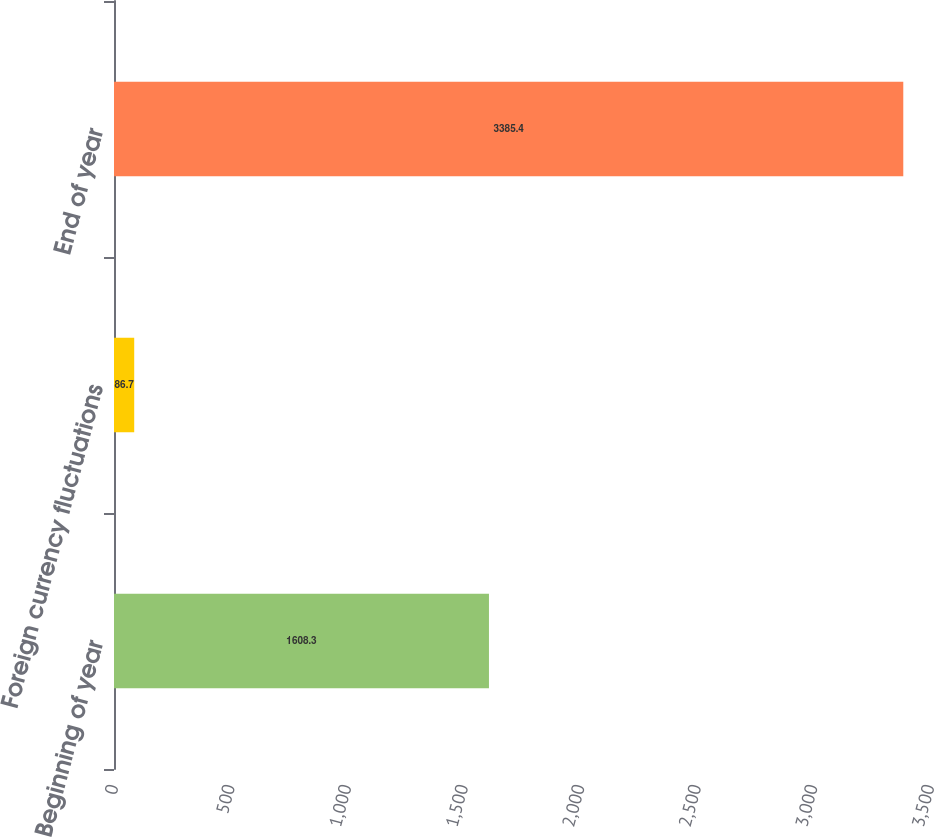<chart> <loc_0><loc_0><loc_500><loc_500><bar_chart><fcel>Beginning of year<fcel>Foreign currency fluctuations<fcel>End of year<nl><fcel>1608.3<fcel>86.7<fcel>3385.4<nl></chart> 